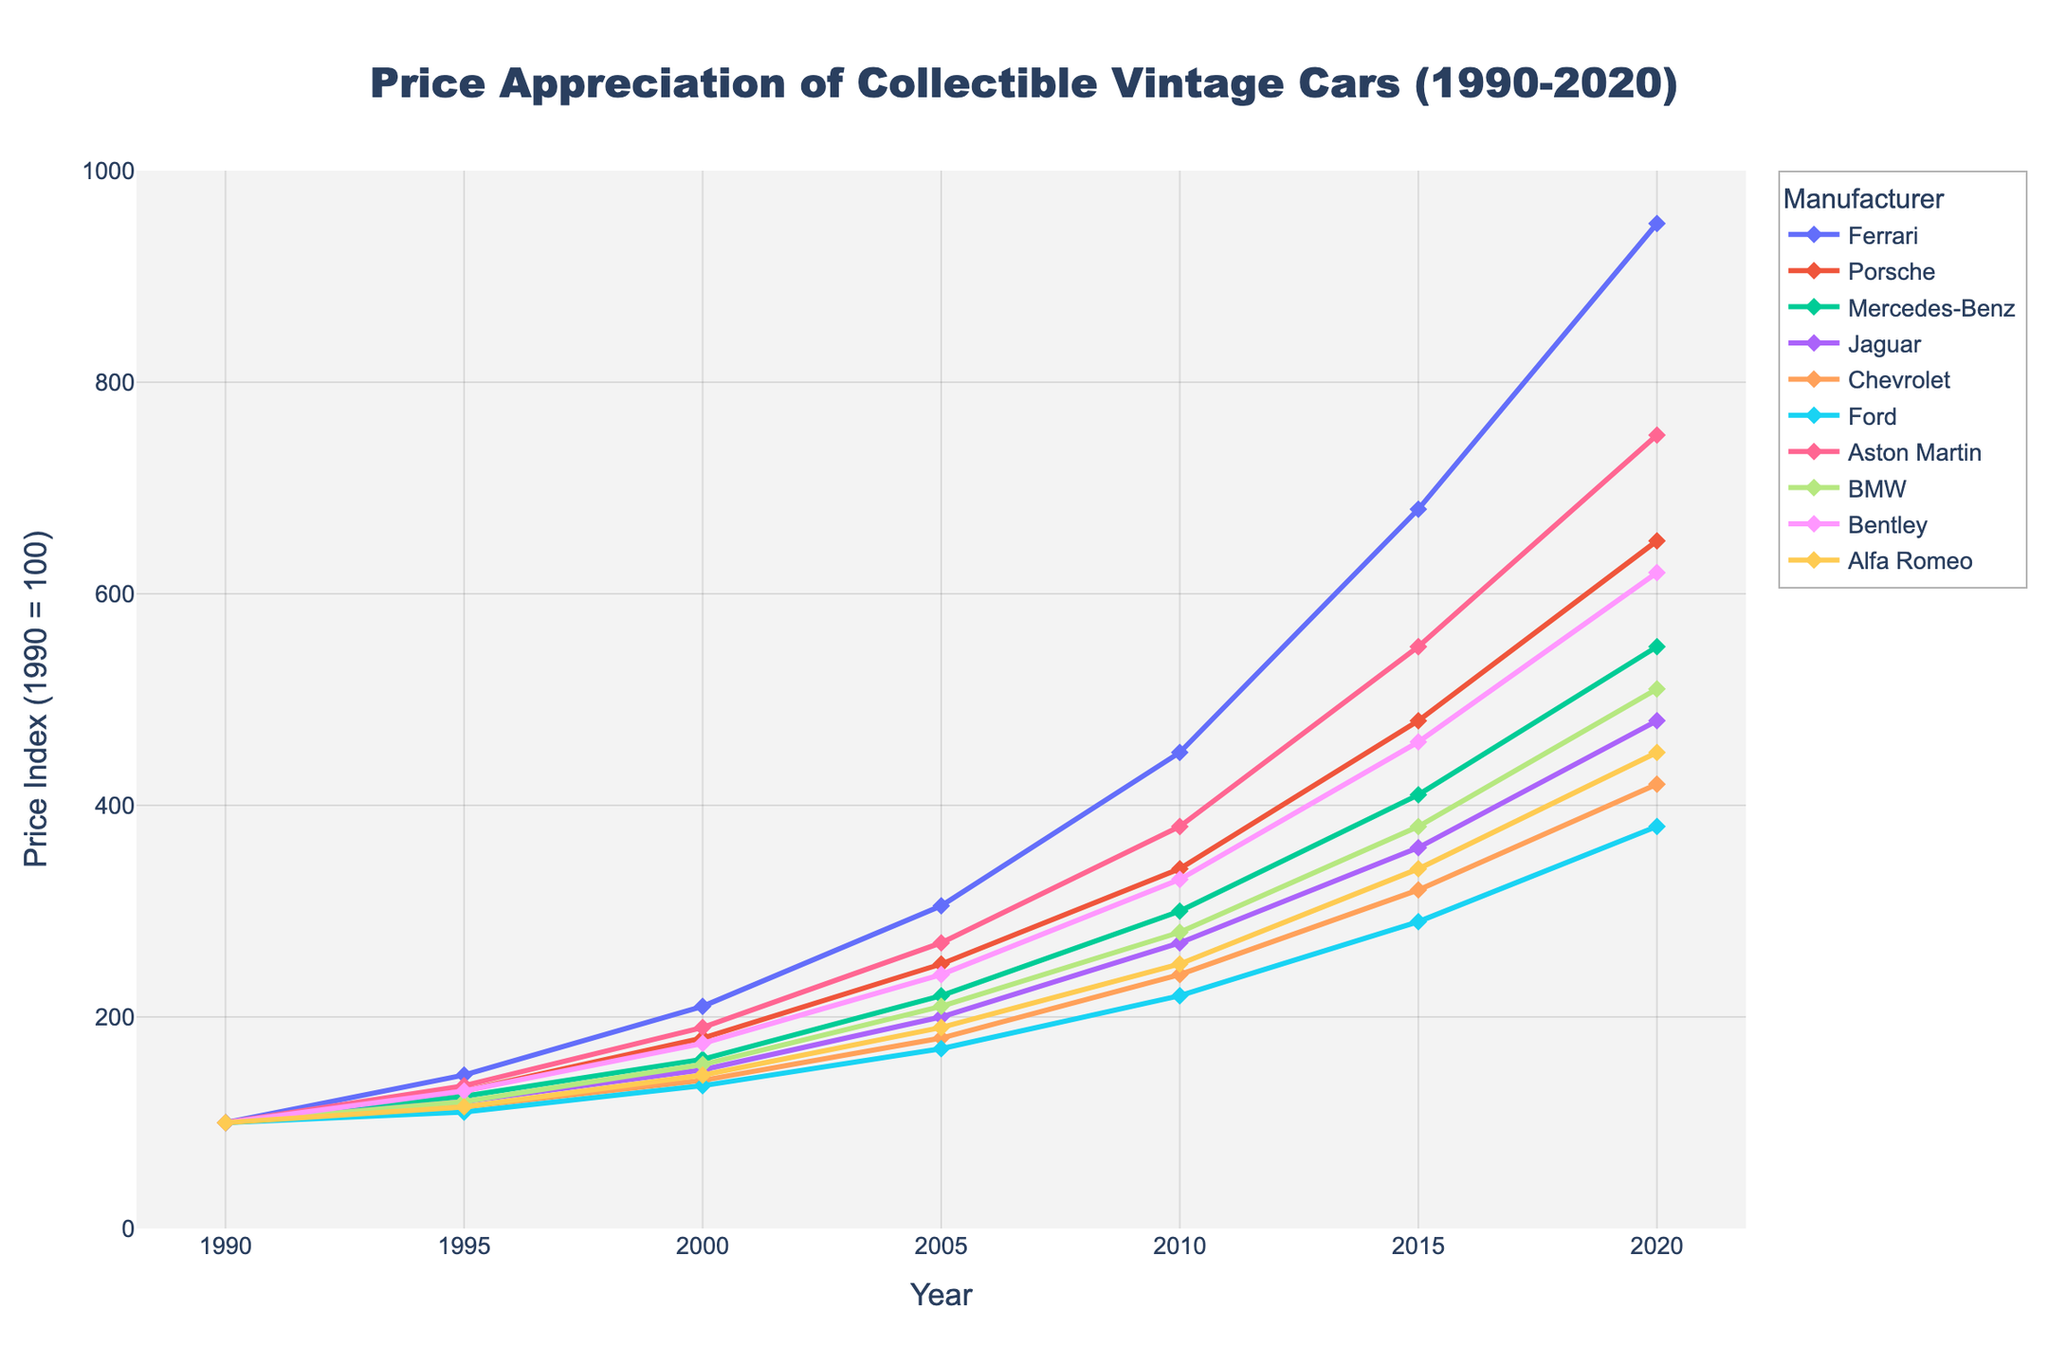What's the overall trend of Ferrari's price appreciation from 1990 to 2020? The price appreciation of Ferrari vintage cars shows a significant upward trend over the 30-year period. It starts at a price index of 100 in 1990 and rises sharply to 950 in 2020.
Answer: Upward trend Which manufacturer had the highest price index in 2000? In the year 2000, the highest price index can be identified by comparing all the values for that year. Ferrari shows the highest price index of 210 in 2000.
Answer: Ferrari By how much did Porsche's price index increase from 1990 to 2020? The price index for Porsche in 1990 was 100, and it increased to 650 in 2020. Therefore, the increase is calculated as 650 - 100 = 550.
Answer: 550 Compare the price appreciation of Jaguar and Chevrolet from 1990 to 2020. Which one appreciated more? Jaguar's price index went from 100 in 1990 to 480 in 2020, resulting in an increase of 380. Chevrolet's index went from 100 to 420, resulting in an increase of 320. Therefore, Jaguar appreciated more.
Answer: Jaguar What is the average price index of Bentley throughout the years provided? Bentley's price indices are 100, 130, 175, 240, 330, 460, and 620. Summing these values and dividing by the number of data points (7) gives (100 + 130 + 175 + 240 + 330 + 460 + 620) / 7 = 293.57.
Answer: 293.57 Which manufacturers had a price index of less than 200 in 2005? For the year 2005, the manufacturers with a price index of less than 200 are Mercedes-Benz (160), Jaguar (150), Chevrolet (140), Ford (135), and Alfa Romeo (145).
Answer: Mercedes-Benz, Jaguar, Chevrolet, Ford, Alfa Romeo By how much did Aston Martin's price index grow on average per decade from 1990 to 2020? Aston Martin's price indices are 100 (1990), 135 (1995), 190 (2000), 270 (2005), 380 (2010), 550 (2015), and 750 (2020). Calculate the increase for each decade and average them: (135-100)+(190-135)+(270-190)+(380-270)+(550-380)+(750-550)/6 = (35+55+80+110+170+200)/6 = 650/6 ≈ 108.33.
Answer: ≈ 108.33 Which manufacturer had the slowest growth in price index from 1990 to 2020? To find the slowest growth, compare the total increase from 1990 to 2020 for all manufacturers. Ford's price index increased from 100 to 380, a growth of 280, which is the smallest increase among all manufacturers.
Answer: Ford What was the average of the price indices for the year 2015 across all manufacturers? Add up the price indices for all manufacturers in 2015 and divide by the number of manufacturers: (680 + 480 + 410 + 360 + 320 + 290 + 550 + 380 + 460 + 340) / 10 = 4270 / 10 = 427.
Answer: 427 